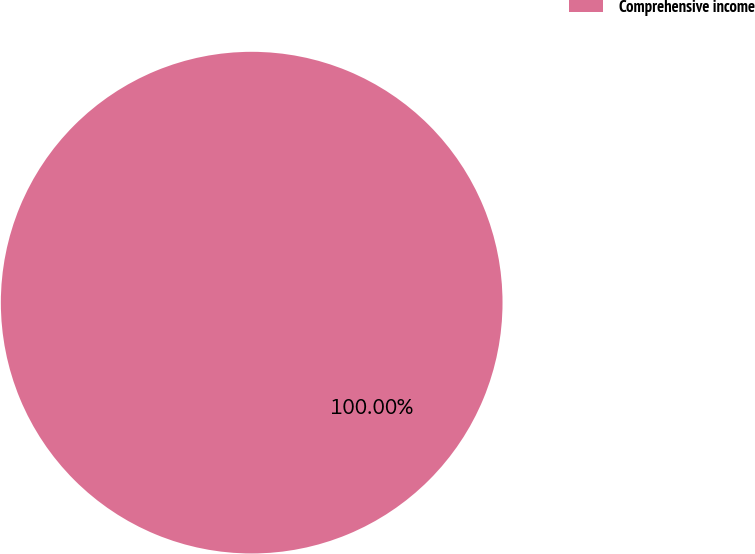Convert chart. <chart><loc_0><loc_0><loc_500><loc_500><pie_chart><fcel>Comprehensive income<nl><fcel>100.0%<nl></chart> 